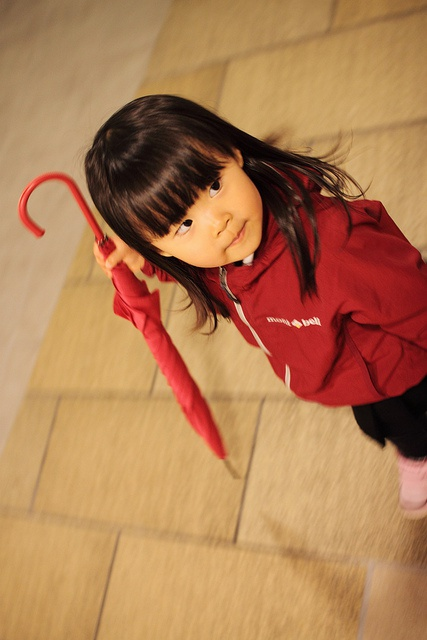Describe the objects in this image and their specific colors. I can see people in brown, black, maroon, and tan tones and umbrella in gray, red, brown, salmon, and tan tones in this image. 